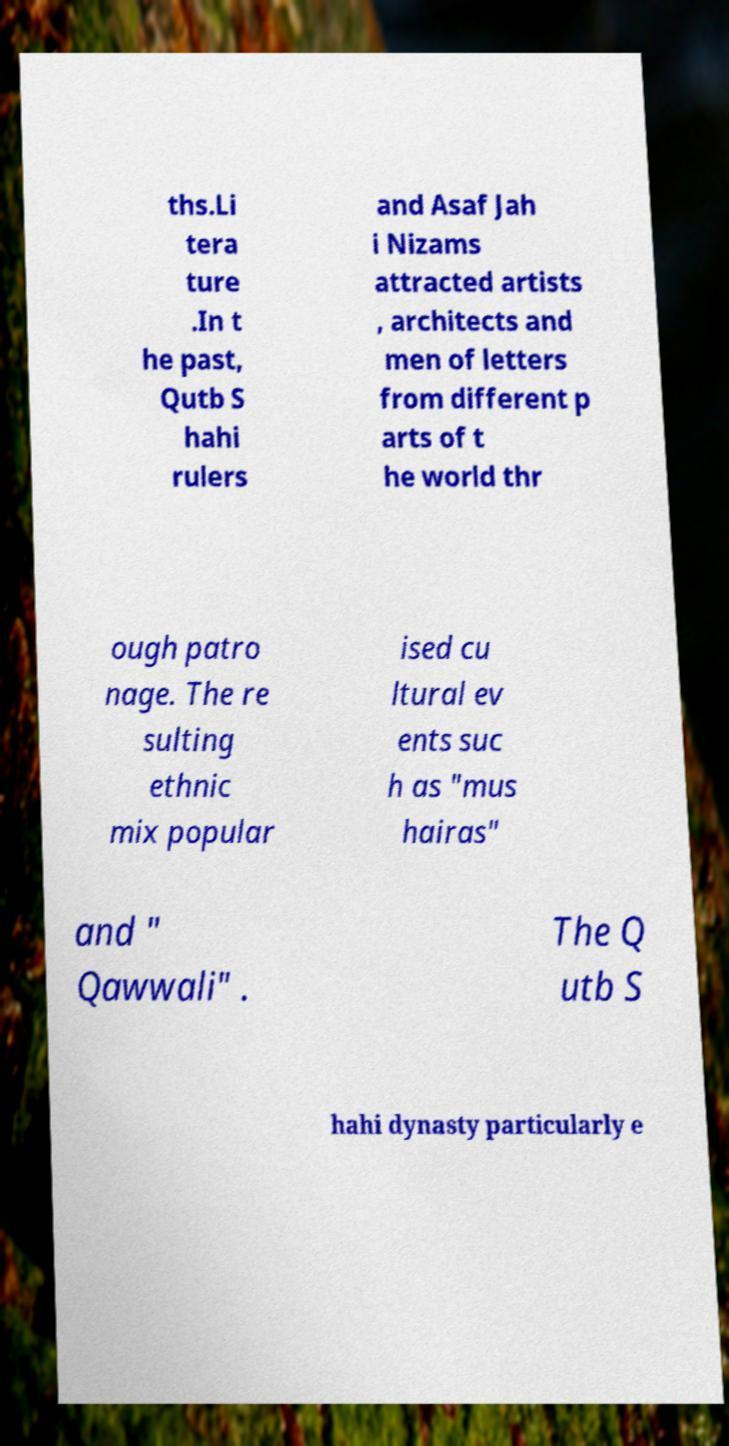What messages or text are displayed in this image? I need them in a readable, typed format. ths.Li tera ture .In t he past, Qutb S hahi rulers and Asaf Jah i Nizams attracted artists , architects and men of letters from different p arts of t he world thr ough patro nage. The re sulting ethnic mix popular ised cu ltural ev ents suc h as "mus hairas" and " Qawwali" . The Q utb S hahi dynasty particularly e 